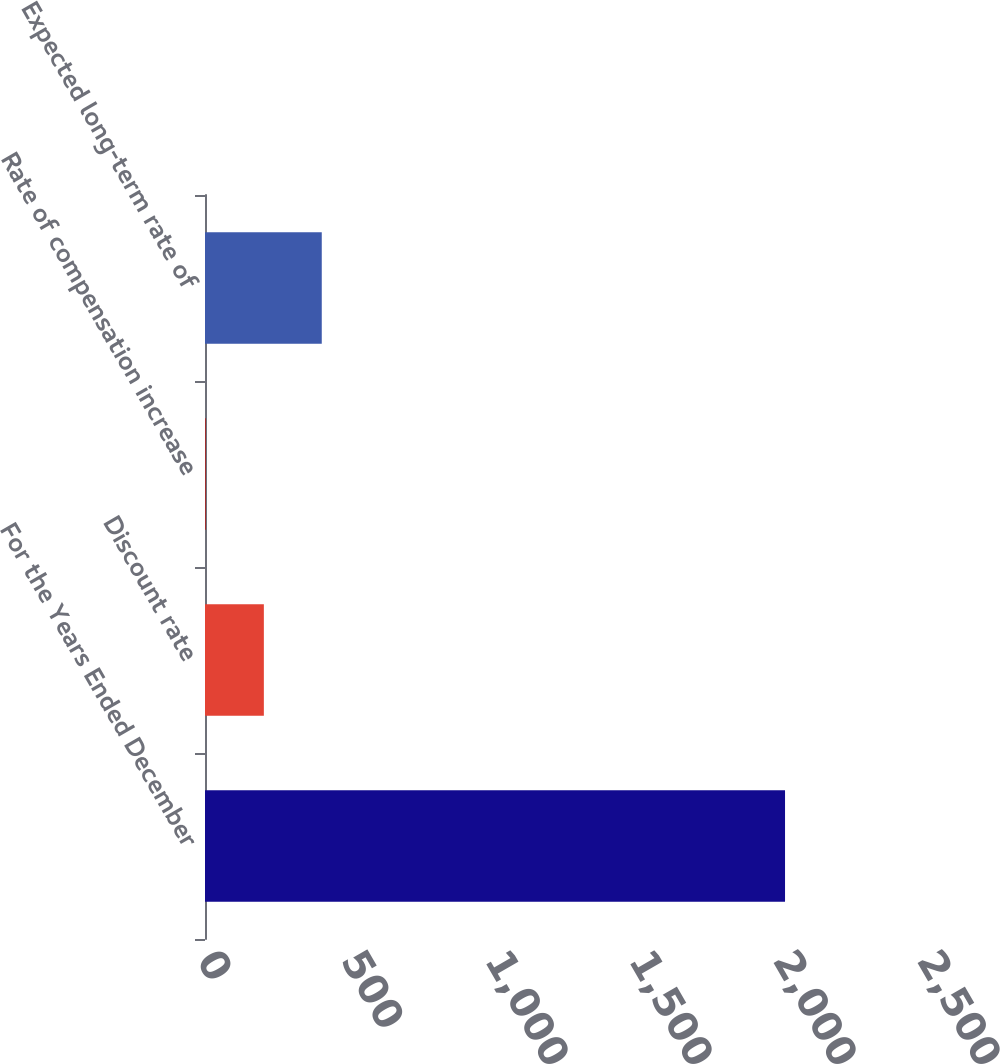Convert chart. <chart><loc_0><loc_0><loc_500><loc_500><bar_chart><fcel>For the Years Ended December<fcel>Discount rate<fcel>Rate of compensation increase<fcel>Expected long-term rate of<nl><fcel>2014<fcel>204.36<fcel>3.29<fcel>405.43<nl></chart> 